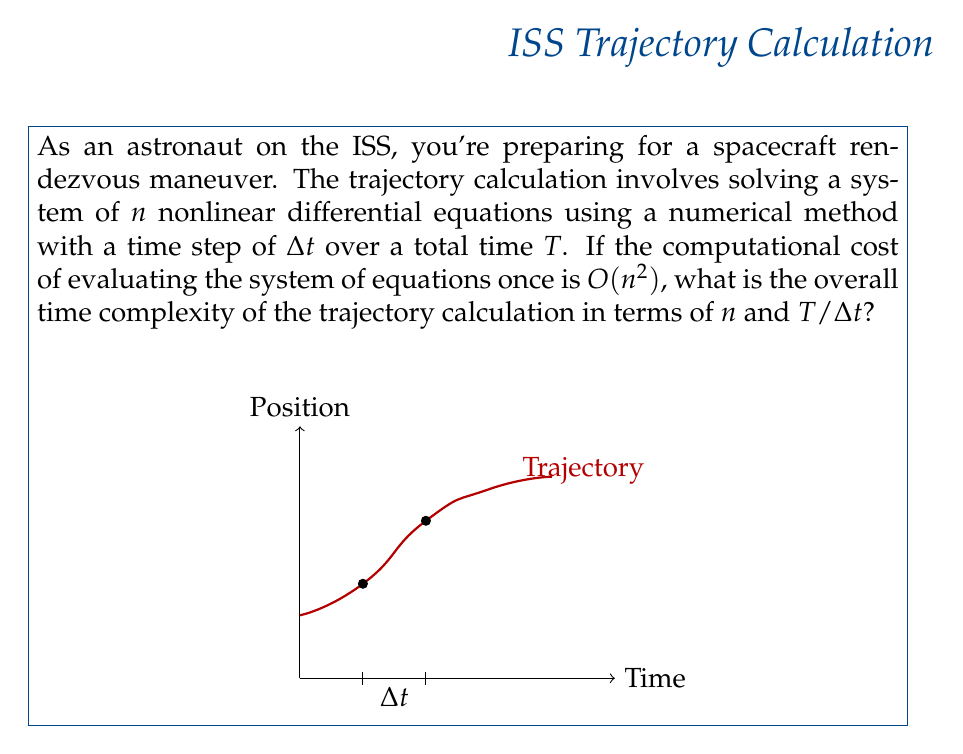Can you answer this question? Let's break this down step-by-step:

1) First, we need to understand what the variables represent:
   - $n$ is the number of differential equations
   - $\Delta t$ is the time step
   - $T$ is the total time
   - $T/\Delta t$ represents the number of time steps

2) We're told that evaluating the system of equations once has a complexity of $O(n^2)$.

3) For each time step, we need to evaluate the system of equations. Most numerical methods for solving differential equations (like Runge-Kutta methods) require multiple evaluations per time step. Let's assume it's a constant number $k$ of evaluations per step.

4) So, for each time step, we're doing $O(kn^2)$ operations. Since $k$ is a constant, this simplifies to $O(n^2)$.

5) We need to do this for each of the $T/\Delta t$ time steps.

6) Therefore, the total number of operations is:

   $$O(n^2 \cdot T/\Delta t)$$

7) This represents the overall time complexity of the trajectory calculation.

Note: In practice, the actual complexity might be higher due to additional operations in the numerical method, but this gives us the dominant term in the complexity.
Answer: $O(n^2 \cdot T/\Delta t)$ 